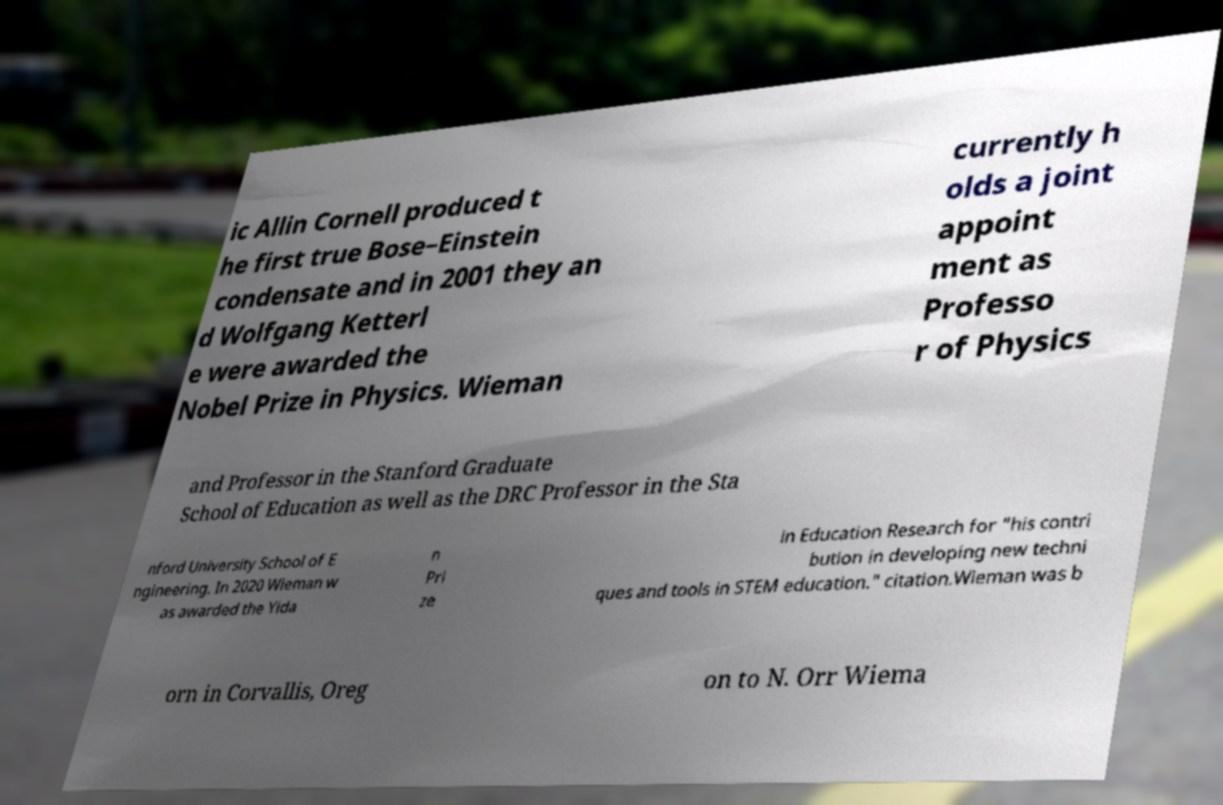For documentation purposes, I need the text within this image transcribed. Could you provide that? ic Allin Cornell produced t he first true Bose–Einstein condensate and in 2001 they an d Wolfgang Ketterl e were awarded the Nobel Prize in Physics. Wieman currently h olds a joint appoint ment as Professo r of Physics and Professor in the Stanford Graduate School of Education as well as the DRC Professor in the Sta nford University School of E ngineering. In 2020 Wieman w as awarded the Yida n Pri ze in Education Research for "his contri bution in developing new techni ques and tools in STEM education." citation.Wieman was b orn in Corvallis, Oreg on to N. Orr Wiema 